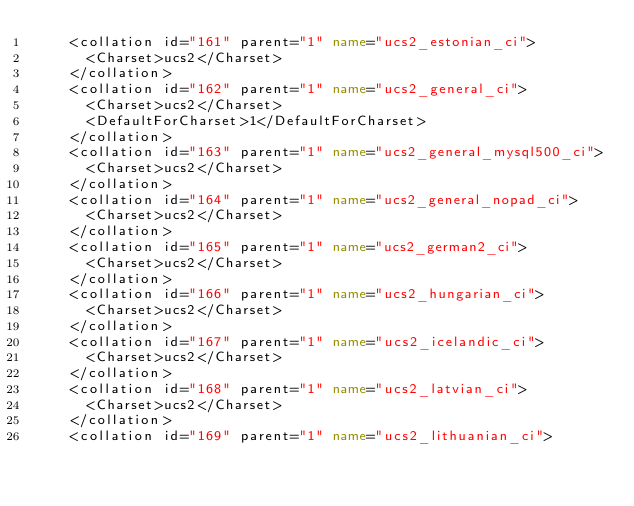Convert code to text. <code><loc_0><loc_0><loc_500><loc_500><_XML_>    <collation id="161" parent="1" name="ucs2_estonian_ci">
      <Charset>ucs2</Charset>
    </collation>
    <collation id="162" parent="1" name="ucs2_general_ci">
      <Charset>ucs2</Charset>
      <DefaultForCharset>1</DefaultForCharset>
    </collation>
    <collation id="163" parent="1" name="ucs2_general_mysql500_ci">
      <Charset>ucs2</Charset>
    </collation>
    <collation id="164" parent="1" name="ucs2_general_nopad_ci">
      <Charset>ucs2</Charset>
    </collation>
    <collation id="165" parent="1" name="ucs2_german2_ci">
      <Charset>ucs2</Charset>
    </collation>
    <collation id="166" parent="1" name="ucs2_hungarian_ci">
      <Charset>ucs2</Charset>
    </collation>
    <collation id="167" parent="1" name="ucs2_icelandic_ci">
      <Charset>ucs2</Charset>
    </collation>
    <collation id="168" parent="1" name="ucs2_latvian_ci">
      <Charset>ucs2</Charset>
    </collation>
    <collation id="169" parent="1" name="ucs2_lithuanian_ci"></code> 